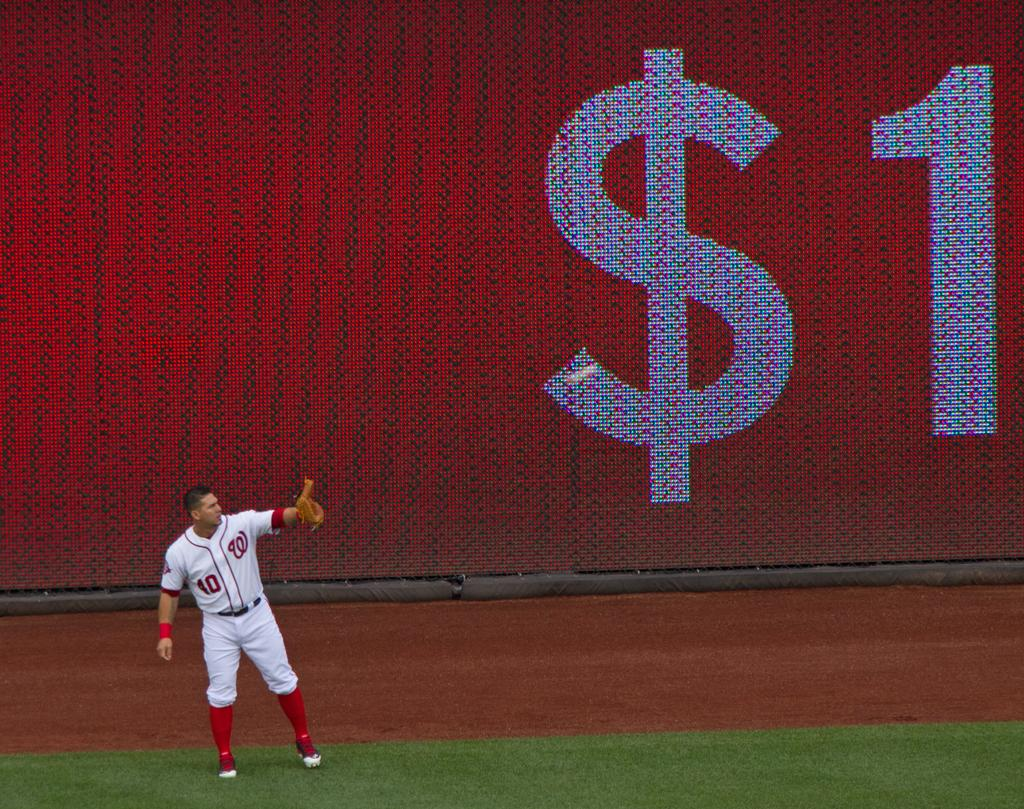<image>
Give a short and clear explanation of the subsequent image. A man dressed in a baseball uniform with 40 on his jersey. 